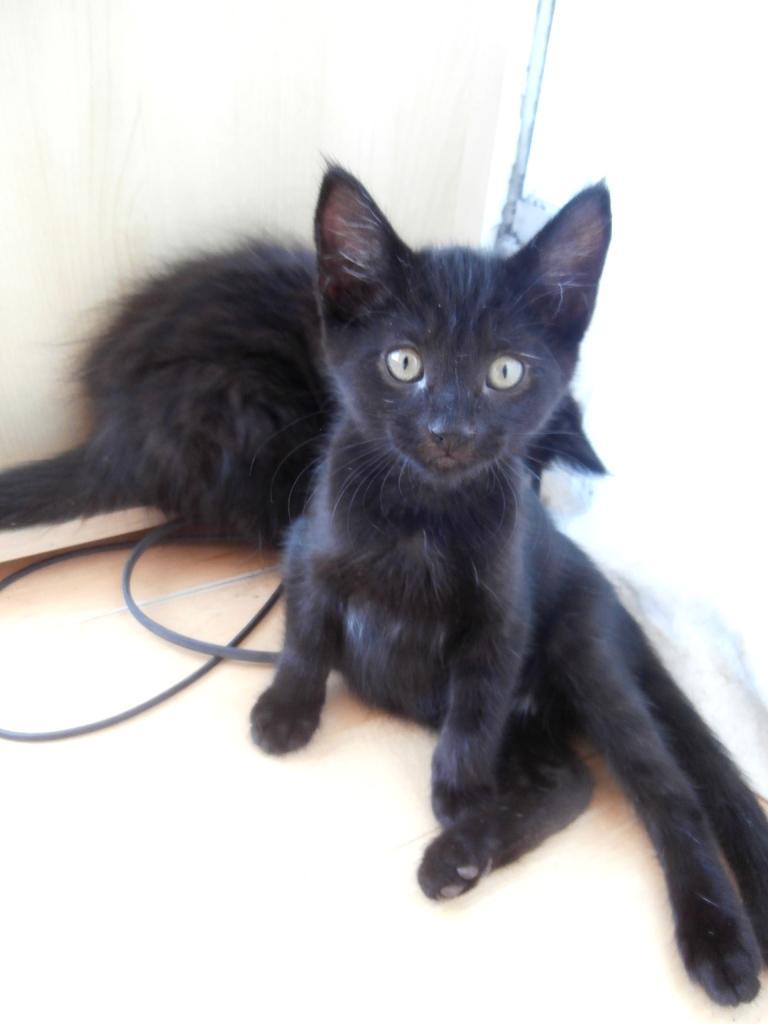In one or two sentences, can you explain what this image depicts? In this picture I can see 2 black color cats in front and I can see the black color wires. I see that it is white color in the background. 